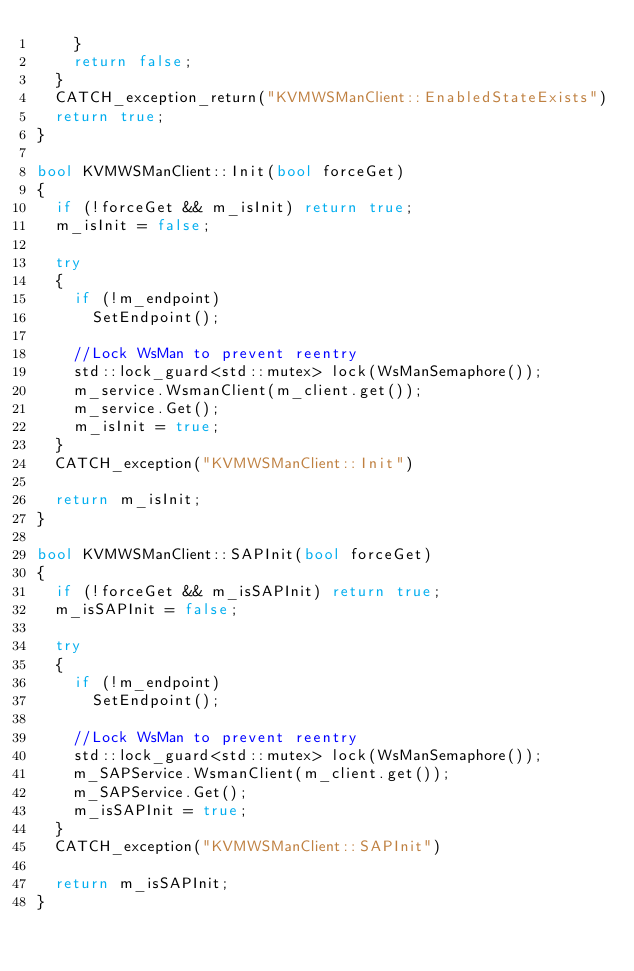<code> <loc_0><loc_0><loc_500><loc_500><_C++_>		}
		return false;
	}
	CATCH_exception_return("KVMWSManClient::EnabledStateExists")
	return true;
}

bool KVMWSManClient::Init(bool forceGet)
{
	if (!forceGet && m_isInit) return true;
	m_isInit = false;
	
	try 
	{
		if (!m_endpoint)
			SetEndpoint();

		//Lock WsMan to prevent reentry
		std::lock_guard<std::mutex> lock(WsManSemaphore());
		m_service.WsmanClient(m_client.get());
		m_service.Get();
		m_isInit = true;
	}
	CATCH_exception("KVMWSManClient::Init")

	return m_isInit;	
}

bool KVMWSManClient::SAPInit(bool forceGet)
{
	if (!forceGet && m_isSAPInit) return true;
	m_isSAPInit = false;
	
	try 
	{
		if (!m_endpoint)
			SetEndpoint();

		//Lock WsMan to prevent reentry
		std::lock_guard<std::mutex> lock(WsManSemaphore());
		m_SAPService.WsmanClient(m_client.get());
		m_SAPService.Get();
		m_isSAPInit = true;
	}
	CATCH_exception("KVMWSManClient::SAPInit")

	return m_isSAPInit;	
}</code> 